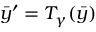Convert formula to latex. <formula><loc_0><loc_0><loc_500><loc_500>\bar { y } ^ { \prime } = T _ { \gamma } ( \bar { y } )</formula> 